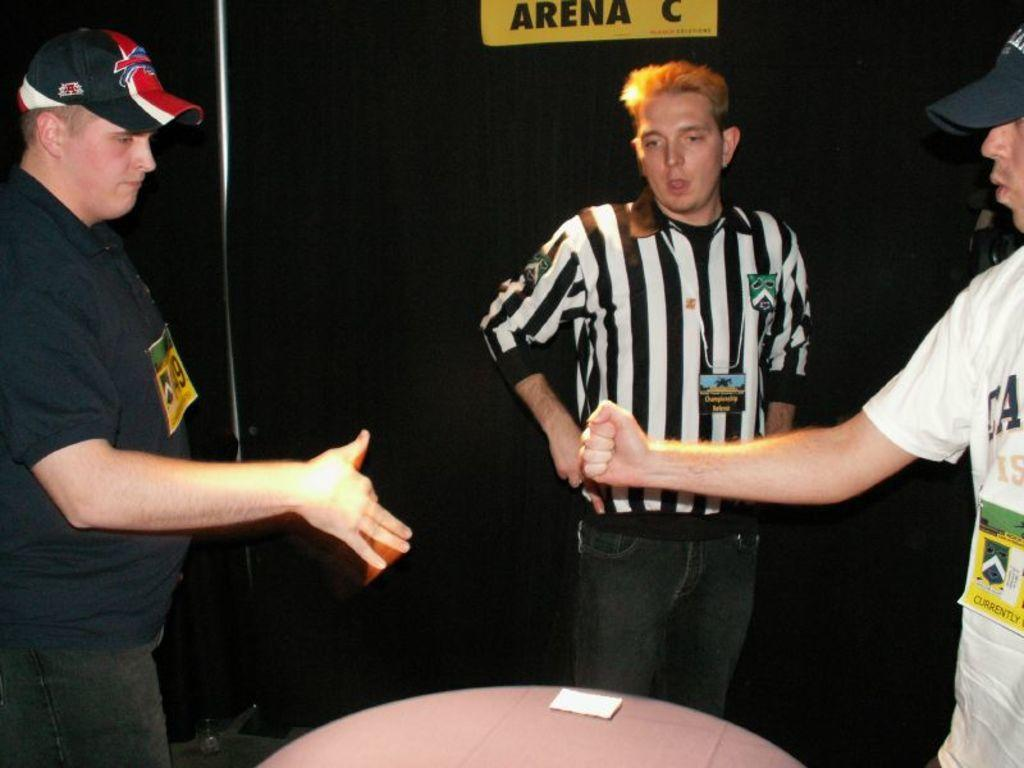Provide a one-sentence caption for the provided image. two men about to hold hands by a sign for Arena C. 